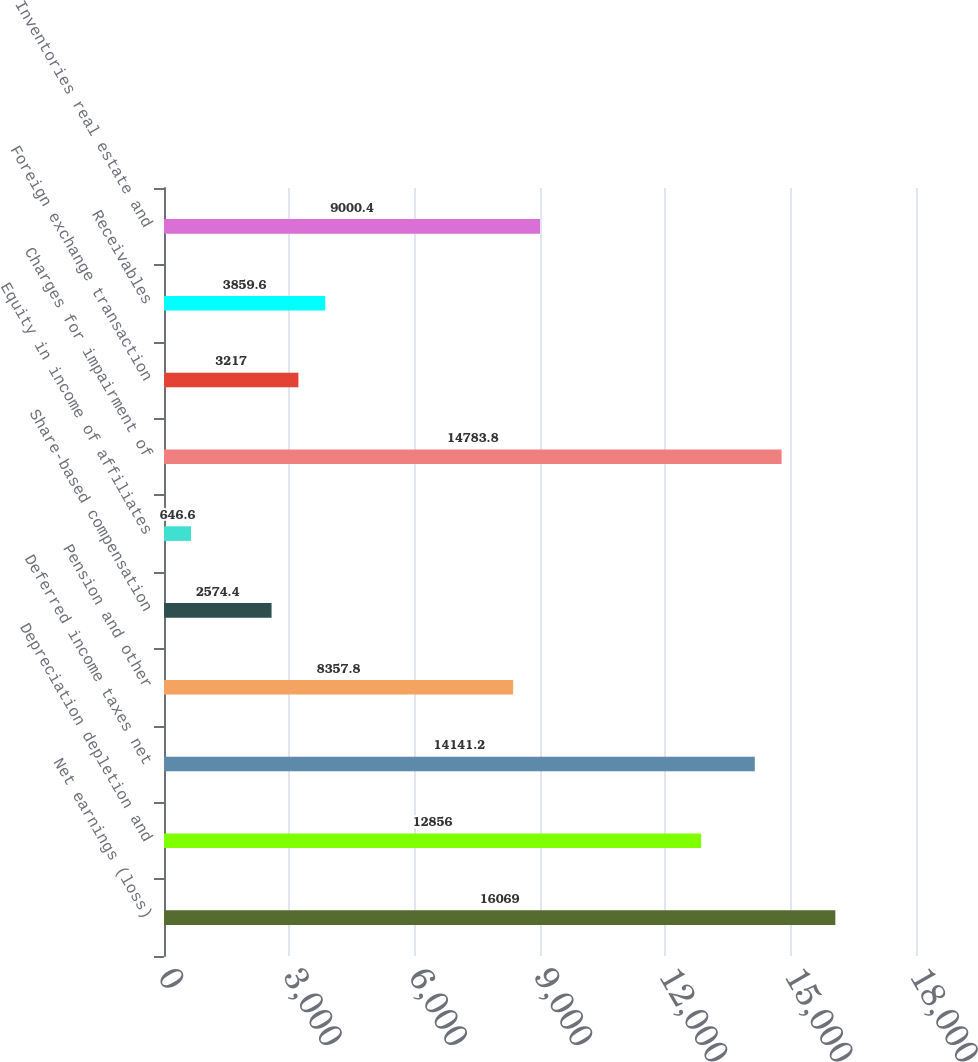Convert chart. <chart><loc_0><loc_0><loc_500><loc_500><bar_chart><fcel>Net earnings (loss)<fcel>Depreciation depletion and<fcel>Deferred income taxes net<fcel>Pension and other<fcel>Share-based compensation<fcel>Equity in income of affiliates<fcel>Charges for impairment of<fcel>Foreign exchange transaction<fcel>Receivables<fcel>Inventories real estate and<nl><fcel>16069<fcel>12856<fcel>14141.2<fcel>8357.8<fcel>2574.4<fcel>646.6<fcel>14783.8<fcel>3217<fcel>3859.6<fcel>9000.4<nl></chart> 